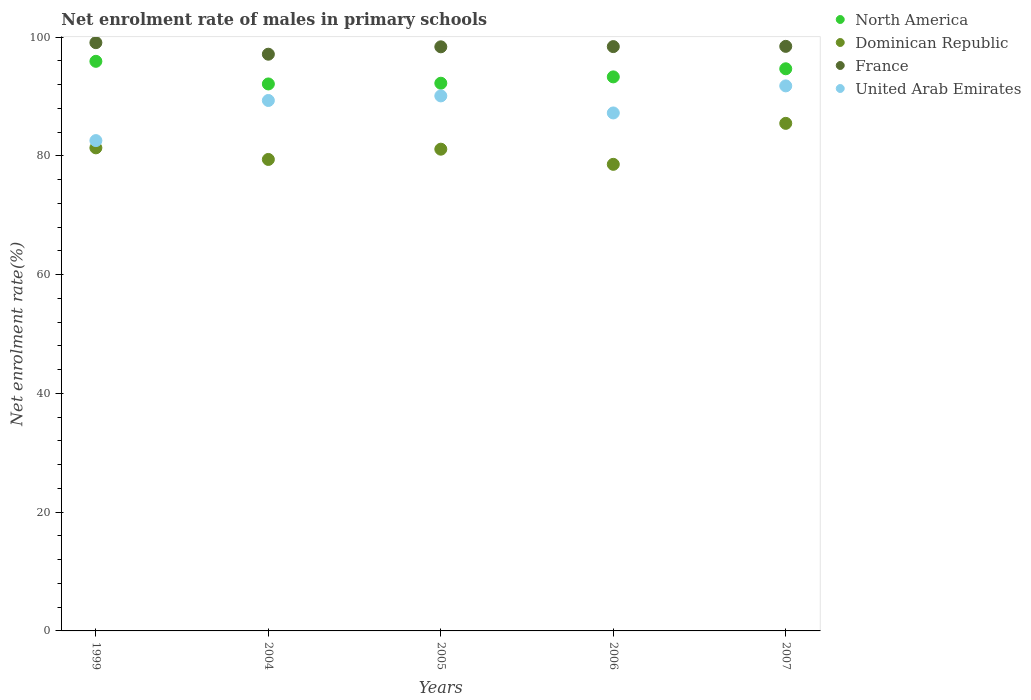How many different coloured dotlines are there?
Your answer should be compact. 4. Is the number of dotlines equal to the number of legend labels?
Offer a very short reply. Yes. What is the net enrolment rate of males in primary schools in United Arab Emirates in 2006?
Your answer should be compact. 87.25. Across all years, what is the maximum net enrolment rate of males in primary schools in United Arab Emirates?
Provide a succinct answer. 91.8. Across all years, what is the minimum net enrolment rate of males in primary schools in Dominican Republic?
Offer a terse response. 78.59. In which year was the net enrolment rate of males in primary schools in France maximum?
Offer a very short reply. 1999. What is the total net enrolment rate of males in primary schools in Dominican Republic in the graph?
Your response must be concise. 406.01. What is the difference between the net enrolment rate of males in primary schools in France in 2004 and that in 2007?
Offer a very short reply. -1.32. What is the difference between the net enrolment rate of males in primary schools in France in 2006 and the net enrolment rate of males in primary schools in United Arab Emirates in 2007?
Keep it short and to the point. 6.62. What is the average net enrolment rate of males in primary schools in United Arab Emirates per year?
Your response must be concise. 88.22. In the year 1999, what is the difference between the net enrolment rate of males in primary schools in France and net enrolment rate of males in primary schools in Dominican Republic?
Provide a short and direct response. 17.72. In how many years, is the net enrolment rate of males in primary schools in North America greater than 84 %?
Your answer should be very brief. 5. What is the ratio of the net enrolment rate of males in primary schools in United Arab Emirates in 1999 to that in 2006?
Offer a very short reply. 0.95. What is the difference between the highest and the second highest net enrolment rate of males in primary schools in United Arab Emirates?
Your answer should be very brief. 1.69. What is the difference between the highest and the lowest net enrolment rate of males in primary schools in Dominican Republic?
Keep it short and to the point. 6.9. Is it the case that in every year, the sum of the net enrolment rate of males in primary schools in North America and net enrolment rate of males in primary schools in France  is greater than the sum of net enrolment rate of males in primary schools in Dominican Republic and net enrolment rate of males in primary schools in United Arab Emirates?
Keep it short and to the point. Yes. Does the net enrolment rate of males in primary schools in Dominican Republic monotonically increase over the years?
Give a very brief answer. No. Is the net enrolment rate of males in primary schools in United Arab Emirates strictly greater than the net enrolment rate of males in primary schools in North America over the years?
Your answer should be very brief. No. How many dotlines are there?
Your answer should be very brief. 4. Does the graph contain any zero values?
Your answer should be compact. No. How are the legend labels stacked?
Make the answer very short. Vertical. What is the title of the graph?
Keep it short and to the point. Net enrolment rate of males in primary schools. Does "Central African Republic" appear as one of the legend labels in the graph?
Offer a very short reply. No. What is the label or title of the X-axis?
Provide a succinct answer. Years. What is the label or title of the Y-axis?
Ensure brevity in your answer.  Net enrolment rate(%). What is the Net enrolment rate(%) in North America in 1999?
Offer a very short reply. 95.94. What is the Net enrolment rate(%) of Dominican Republic in 1999?
Keep it short and to the point. 81.37. What is the Net enrolment rate(%) in France in 1999?
Your answer should be compact. 99.09. What is the Net enrolment rate(%) of United Arab Emirates in 1999?
Give a very brief answer. 82.59. What is the Net enrolment rate(%) in North America in 2004?
Give a very brief answer. 92.13. What is the Net enrolment rate(%) of Dominican Republic in 2004?
Give a very brief answer. 79.41. What is the Net enrolment rate(%) of France in 2004?
Your answer should be very brief. 97.14. What is the Net enrolment rate(%) of United Arab Emirates in 2004?
Your answer should be compact. 89.35. What is the Net enrolment rate(%) of North America in 2005?
Provide a succinct answer. 92.25. What is the Net enrolment rate(%) in Dominican Republic in 2005?
Provide a short and direct response. 81.14. What is the Net enrolment rate(%) of France in 2005?
Your answer should be very brief. 98.39. What is the Net enrolment rate(%) in United Arab Emirates in 2005?
Keep it short and to the point. 90.12. What is the Net enrolment rate(%) in North America in 2006?
Provide a succinct answer. 93.32. What is the Net enrolment rate(%) of Dominican Republic in 2006?
Make the answer very short. 78.59. What is the Net enrolment rate(%) in France in 2006?
Your response must be concise. 98.42. What is the Net enrolment rate(%) of United Arab Emirates in 2006?
Your answer should be compact. 87.25. What is the Net enrolment rate(%) of North America in 2007?
Your answer should be compact. 94.69. What is the Net enrolment rate(%) of Dominican Republic in 2007?
Offer a very short reply. 85.49. What is the Net enrolment rate(%) of France in 2007?
Provide a short and direct response. 98.46. What is the Net enrolment rate(%) in United Arab Emirates in 2007?
Give a very brief answer. 91.8. Across all years, what is the maximum Net enrolment rate(%) in North America?
Ensure brevity in your answer.  95.94. Across all years, what is the maximum Net enrolment rate(%) of Dominican Republic?
Offer a terse response. 85.49. Across all years, what is the maximum Net enrolment rate(%) of France?
Ensure brevity in your answer.  99.09. Across all years, what is the maximum Net enrolment rate(%) in United Arab Emirates?
Ensure brevity in your answer.  91.8. Across all years, what is the minimum Net enrolment rate(%) of North America?
Provide a succinct answer. 92.13. Across all years, what is the minimum Net enrolment rate(%) in Dominican Republic?
Your response must be concise. 78.59. Across all years, what is the minimum Net enrolment rate(%) of France?
Offer a terse response. 97.14. Across all years, what is the minimum Net enrolment rate(%) in United Arab Emirates?
Ensure brevity in your answer.  82.59. What is the total Net enrolment rate(%) in North America in the graph?
Make the answer very short. 468.33. What is the total Net enrolment rate(%) of Dominican Republic in the graph?
Give a very brief answer. 406.01. What is the total Net enrolment rate(%) in France in the graph?
Provide a short and direct response. 491.49. What is the total Net enrolment rate(%) in United Arab Emirates in the graph?
Keep it short and to the point. 441.1. What is the difference between the Net enrolment rate(%) in North America in 1999 and that in 2004?
Ensure brevity in your answer.  3.81. What is the difference between the Net enrolment rate(%) of Dominican Republic in 1999 and that in 2004?
Offer a terse response. 1.95. What is the difference between the Net enrolment rate(%) in France in 1999 and that in 2004?
Your answer should be compact. 1.95. What is the difference between the Net enrolment rate(%) of United Arab Emirates in 1999 and that in 2004?
Give a very brief answer. -6.76. What is the difference between the Net enrolment rate(%) in North America in 1999 and that in 2005?
Provide a short and direct response. 3.69. What is the difference between the Net enrolment rate(%) of Dominican Republic in 1999 and that in 2005?
Offer a very short reply. 0.23. What is the difference between the Net enrolment rate(%) of United Arab Emirates in 1999 and that in 2005?
Give a very brief answer. -7.53. What is the difference between the Net enrolment rate(%) in North America in 1999 and that in 2006?
Give a very brief answer. 2.62. What is the difference between the Net enrolment rate(%) in Dominican Republic in 1999 and that in 2006?
Your answer should be compact. 2.78. What is the difference between the Net enrolment rate(%) of France in 1999 and that in 2006?
Your answer should be compact. 0.66. What is the difference between the Net enrolment rate(%) of United Arab Emirates in 1999 and that in 2006?
Make the answer very short. -4.66. What is the difference between the Net enrolment rate(%) in North America in 1999 and that in 2007?
Give a very brief answer. 1.26. What is the difference between the Net enrolment rate(%) in Dominican Republic in 1999 and that in 2007?
Your answer should be compact. -4.13. What is the difference between the Net enrolment rate(%) of France in 1999 and that in 2007?
Your answer should be compact. 0.62. What is the difference between the Net enrolment rate(%) of United Arab Emirates in 1999 and that in 2007?
Give a very brief answer. -9.22. What is the difference between the Net enrolment rate(%) in North America in 2004 and that in 2005?
Your answer should be compact. -0.12. What is the difference between the Net enrolment rate(%) in Dominican Republic in 2004 and that in 2005?
Make the answer very short. -1.73. What is the difference between the Net enrolment rate(%) of France in 2004 and that in 2005?
Provide a succinct answer. -1.25. What is the difference between the Net enrolment rate(%) of United Arab Emirates in 2004 and that in 2005?
Your answer should be very brief. -0.77. What is the difference between the Net enrolment rate(%) of North America in 2004 and that in 2006?
Provide a short and direct response. -1.19. What is the difference between the Net enrolment rate(%) in Dominican Republic in 2004 and that in 2006?
Give a very brief answer. 0.83. What is the difference between the Net enrolment rate(%) in France in 2004 and that in 2006?
Offer a terse response. -1.28. What is the difference between the Net enrolment rate(%) of United Arab Emirates in 2004 and that in 2006?
Provide a short and direct response. 2.1. What is the difference between the Net enrolment rate(%) in North America in 2004 and that in 2007?
Your response must be concise. -2.55. What is the difference between the Net enrolment rate(%) of Dominican Republic in 2004 and that in 2007?
Provide a short and direct response. -6.08. What is the difference between the Net enrolment rate(%) of France in 2004 and that in 2007?
Ensure brevity in your answer.  -1.32. What is the difference between the Net enrolment rate(%) in United Arab Emirates in 2004 and that in 2007?
Give a very brief answer. -2.46. What is the difference between the Net enrolment rate(%) of North America in 2005 and that in 2006?
Your response must be concise. -1.07. What is the difference between the Net enrolment rate(%) in Dominican Republic in 2005 and that in 2006?
Keep it short and to the point. 2.55. What is the difference between the Net enrolment rate(%) in France in 2005 and that in 2006?
Offer a terse response. -0.04. What is the difference between the Net enrolment rate(%) in United Arab Emirates in 2005 and that in 2006?
Your response must be concise. 2.87. What is the difference between the Net enrolment rate(%) in North America in 2005 and that in 2007?
Offer a very short reply. -2.43. What is the difference between the Net enrolment rate(%) of Dominican Republic in 2005 and that in 2007?
Provide a succinct answer. -4.35. What is the difference between the Net enrolment rate(%) of France in 2005 and that in 2007?
Provide a succinct answer. -0.08. What is the difference between the Net enrolment rate(%) of United Arab Emirates in 2005 and that in 2007?
Your answer should be very brief. -1.69. What is the difference between the Net enrolment rate(%) in North America in 2006 and that in 2007?
Provide a succinct answer. -1.37. What is the difference between the Net enrolment rate(%) of Dominican Republic in 2006 and that in 2007?
Offer a terse response. -6.9. What is the difference between the Net enrolment rate(%) in France in 2006 and that in 2007?
Your answer should be compact. -0.04. What is the difference between the Net enrolment rate(%) in United Arab Emirates in 2006 and that in 2007?
Offer a terse response. -4.56. What is the difference between the Net enrolment rate(%) of North America in 1999 and the Net enrolment rate(%) of Dominican Republic in 2004?
Your response must be concise. 16.53. What is the difference between the Net enrolment rate(%) in North America in 1999 and the Net enrolment rate(%) in France in 2004?
Your answer should be very brief. -1.2. What is the difference between the Net enrolment rate(%) in North America in 1999 and the Net enrolment rate(%) in United Arab Emirates in 2004?
Ensure brevity in your answer.  6.6. What is the difference between the Net enrolment rate(%) in Dominican Republic in 1999 and the Net enrolment rate(%) in France in 2004?
Provide a succinct answer. -15.77. What is the difference between the Net enrolment rate(%) in Dominican Republic in 1999 and the Net enrolment rate(%) in United Arab Emirates in 2004?
Your answer should be very brief. -7.98. What is the difference between the Net enrolment rate(%) of France in 1999 and the Net enrolment rate(%) of United Arab Emirates in 2004?
Provide a short and direct response. 9.74. What is the difference between the Net enrolment rate(%) of North America in 1999 and the Net enrolment rate(%) of Dominican Republic in 2005?
Make the answer very short. 14.8. What is the difference between the Net enrolment rate(%) in North America in 1999 and the Net enrolment rate(%) in France in 2005?
Offer a terse response. -2.44. What is the difference between the Net enrolment rate(%) of North America in 1999 and the Net enrolment rate(%) of United Arab Emirates in 2005?
Provide a short and direct response. 5.82. What is the difference between the Net enrolment rate(%) of Dominican Republic in 1999 and the Net enrolment rate(%) of France in 2005?
Offer a very short reply. -17.02. What is the difference between the Net enrolment rate(%) in Dominican Republic in 1999 and the Net enrolment rate(%) in United Arab Emirates in 2005?
Make the answer very short. -8.75. What is the difference between the Net enrolment rate(%) in France in 1999 and the Net enrolment rate(%) in United Arab Emirates in 2005?
Your response must be concise. 8.97. What is the difference between the Net enrolment rate(%) of North America in 1999 and the Net enrolment rate(%) of Dominican Republic in 2006?
Your answer should be compact. 17.35. What is the difference between the Net enrolment rate(%) of North America in 1999 and the Net enrolment rate(%) of France in 2006?
Give a very brief answer. -2.48. What is the difference between the Net enrolment rate(%) in North America in 1999 and the Net enrolment rate(%) in United Arab Emirates in 2006?
Offer a very short reply. 8.7. What is the difference between the Net enrolment rate(%) of Dominican Republic in 1999 and the Net enrolment rate(%) of France in 2006?
Provide a short and direct response. -17.05. What is the difference between the Net enrolment rate(%) of Dominican Republic in 1999 and the Net enrolment rate(%) of United Arab Emirates in 2006?
Your answer should be very brief. -5.88. What is the difference between the Net enrolment rate(%) of France in 1999 and the Net enrolment rate(%) of United Arab Emirates in 2006?
Offer a terse response. 11.84. What is the difference between the Net enrolment rate(%) in North America in 1999 and the Net enrolment rate(%) in Dominican Republic in 2007?
Keep it short and to the point. 10.45. What is the difference between the Net enrolment rate(%) in North America in 1999 and the Net enrolment rate(%) in France in 2007?
Make the answer very short. -2.52. What is the difference between the Net enrolment rate(%) of North America in 1999 and the Net enrolment rate(%) of United Arab Emirates in 2007?
Offer a terse response. 4.14. What is the difference between the Net enrolment rate(%) of Dominican Republic in 1999 and the Net enrolment rate(%) of France in 2007?
Offer a very short reply. -17.09. What is the difference between the Net enrolment rate(%) of Dominican Republic in 1999 and the Net enrolment rate(%) of United Arab Emirates in 2007?
Give a very brief answer. -10.44. What is the difference between the Net enrolment rate(%) of France in 1999 and the Net enrolment rate(%) of United Arab Emirates in 2007?
Keep it short and to the point. 7.28. What is the difference between the Net enrolment rate(%) of North America in 2004 and the Net enrolment rate(%) of Dominican Republic in 2005?
Ensure brevity in your answer.  10.99. What is the difference between the Net enrolment rate(%) of North America in 2004 and the Net enrolment rate(%) of France in 2005?
Provide a succinct answer. -6.25. What is the difference between the Net enrolment rate(%) of North America in 2004 and the Net enrolment rate(%) of United Arab Emirates in 2005?
Your answer should be compact. 2.01. What is the difference between the Net enrolment rate(%) of Dominican Republic in 2004 and the Net enrolment rate(%) of France in 2005?
Your response must be concise. -18.97. What is the difference between the Net enrolment rate(%) of Dominican Republic in 2004 and the Net enrolment rate(%) of United Arab Emirates in 2005?
Offer a very short reply. -10.7. What is the difference between the Net enrolment rate(%) in France in 2004 and the Net enrolment rate(%) in United Arab Emirates in 2005?
Offer a very short reply. 7.02. What is the difference between the Net enrolment rate(%) in North America in 2004 and the Net enrolment rate(%) in Dominican Republic in 2006?
Give a very brief answer. 13.54. What is the difference between the Net enrolment rate(%) in North America in 2004 and the Net enrolment rate(%) in France in 2006?
Your response must be concise. -6.29. What is the difference between the Net enrolment rate(%) of North America in 2004 and the Net enrolment rate(%) of United Arab Emirates in 2006?
Provide a succinct answer. 4.89. What is the difference between the Net enrolment rate(%) of Dominican Republic in 2004 and the Net enrolment rate(%) of France in 2006?
Ensure brevity in your answer.  -19.01. What is the difference between the Net enrolment rate(%) in Dominican Republic in 2004 and the Net enrolment rate(%) in United Arab Emirates in 2006?
Your answer should be compact. -7.83. What is the difference between the Net enrolment rate(%) in France in 2004 and the Net enrolment rate(%) in United Arab Emirates in 2006?
Give a very brief answer. 9.89. What is the difference between the Net enrolment rate(%) of North America in 2004 and the Net enrolment rate(%) of Dominican Republic in 2007?
Offer a very short reply. 6.64. What is the difference between the Net enrolment rate(%) in North America in 2004 and the Net enrolment rate(%) in France in 2007?
Give a very brief answer. -6.33. What is the difference between the Net enrolment rate(%) of North America in 2004 and the Net enrolment rate(%) of United Arab Emirates in 2007?
Make the answer very short. 0.33. What is the difference between the Net enrolment rate(%) of Dominican Republic in 2004 and the Net enrolment rate(%) of France in 2007?
Offer a terse response. -19.05. What is the difference between the Net enrolment rate(%) in Dominican Republic in 2004 and the Net enrolment rate(%) in United Arab Emirates in 2007?
Provide a succinct answer. -12.39. What is the difference between the Net enrolment rate(%) of France in 2004 and the Net enrolment rate(%) of United Arab Emirates in 2007?
Give a very brief answer. 5.34. What is the difference between the Net enrolment rate(%) in North America in 2005 and the Net enrolment rate(%) in Dominican Republic in 2006?
Offer a very short reply. 13.66. What is the difference between the Net enrolment rate(%) of North America in 2005 and the Net enrolment rate(%) of France in 2006?
Provide a succinct answer. -6.17. What is the difference between the Net enrolment rate(%) in North America in 2005 and the Net enrolment rate(%) in United Arab Emirates in 2006?
Give a very brief answer. 5.01. What is the difference between the Net enrolment rate(%) in Dominican Republic in 2005 and the Net enrolment rate(%) in France in 2006?
Your response must be concise. -17.28. What is the difference between the Net enrolment rate(%) of Dominican Republic in 2005 and the Net enrolment rate(%) of United Arab Emirates in 2006?
Keep it short and to the point. -6.1. What is the difference between the Net enrolment rate(%) of France in 2005 and the Net enrolment rate(%) of United Arab Emirates in 2006?
Your answer should be very brief. 11.14. What is the difference between the Net enrolment rate(%) of North America in 2005 and the Net enrolment rate(%) of Dominican Republic in 2007?
Your answer should be compact. 6.76. What is the difference between the Net enrolment rate(%) of North America in 2005 and the Net enrolment rate(%) of France in 2007?
Keep it short and to the point. -6.21. What is the difference between the Net enrolment rate(%) in North America in 2005 and the Net enrolment rate(%) in United Arab Emirates in 2007?
Keep it short and to the point. 0.45. What is the difference between the Net enrolment rate(%) of Dominican Republic in 2005 and the Net enrolment rate(%) of France in 2007?
Give a very brief answer. -17.32. What is the difference between the Net enrolment rate(%) in Dominican Republic in 2005 and the Net enrolment rate(%) in United Arab Emirates in 2007?
Your answer should be very brief. -10.66. What is the difference between the Net enrolment rate(%) in France in 2005 and the Net enrolment rate(%) in United Arab Emirates in 2007?
Make the answer very short. 6.58. What is the difference between the Net enrolment rate(%) in North America in 2006 and the Net enrolment rate(%) in Dominican Republic in 2007?
Ensure brevity in your answer.  7.83. What is the difference between the Net enrolment rate(%) of North America in 2006 and the Net enrolment rate(%) of France in 2007?
Offer a terse response. -5.14. What is the difference between the Net enrolment rate(%) in North America in 2006 and the Net enrolment rate(%) in United Arab Emirates in 2007?
Your answer should be compact. 1.52. What is the difference between the Net enrolment rate(%) in Dominican Republic in 2006 and the Net enrolment rate(%) in France in 2007?
Your answer should be very brief. -19.87. What is the difference between the Net enrolment rate(%) of Dominican Republic in 2006 and the Net enrolment rate(%) of United Arab Emirates in 2007?
Offer a terse response. -13.21. What is the difference between the Net enrolment rate(%) in France in 2006 and the Net enrolment rate(%) in United Arab Emirates in 2007?
Provide a succinct answer. 6.62. What is the average Net enrolment rate(%) of North America per year?
Your answer should be very brief. 93.67. What is the average Net enrolment rate(%) in Dominican Republic per year?
Your answer should be very brief. 81.2. What is the average Net enrolment rate(%) of France per year?
Make the answer very short. 98.3. What is the average Net enrolment rate(%) of United Arab Emirates per year?
Provide a succinct answer. 88.22. In the year 1999, what is the difference between the Net enrolment rate(%) of North America and Net enrolment rate(%) of Dominican Republic?
Provide a short and direct response. 14.57. In the year 1999, what is the difference between the Net enrolment rate(%) of North America and Net enrolment rate(%) of France?
Provide a succinct answer. -3.14. In the year 1999, what is the difference between the Net enrolment rate(%) of North America and Net enrolment rate(%) of United Arab Emirates?
Keep it short and to the point. 13.35. In the year 1999, what is the difference between the Net enrolment rate(%) in Dominican Republic and Net enrolment rate(%) in France?
Provide a short and direct response. -17.72. In the year 1999, what is the difference between the Net enrolment rate(%) in Dominican Republic and Net enrolment rate(%) in United Arab Emirates?
Offer a very short reply. -1.22. In the year 1999, what is the difference between the Net enrolment rate(%) in France and Net enrolment rate(%) in United Arab Emirates?
Offer a terse response. 16.5. In the year 2004, what is the difference between the Net enrolment rate(%) of North America and Net enrolment rate(%) of Dominican Republic?
Provide a short and direct response. 12.72. In the year 2004, what is the difference between the Net enrolment rate(%) of North America and Net enrolment rate(%) of France?
Your answer should be very brief. -5.01. In the year 2004, what is the difference between the Net enrolment rate(%) in North America and Net enrolment rate(%) in United Arab Emirates?
Give a very brief answer. 2.79. In the year 2004, what is the difference between the Net enrolment rate(%) of Dominican Republic and Net enrolment rate(%) of France?
Make the answer very short. -17.72. In the year 2004, what is the difference between the Net enrolment rate(%) in Dominican Republic and Net enrolment rate(%) in United Arab Emirates?
Your response must be concise. -9.93. In the year 2004, what is the difference between the Net enrolment rate(%) in France and Net enrolment rate(%) in United Arab Emirates?
Your response must be concise. 7.79. In the year 2005, what is the difference between the Net enrolment rate(%) in North America and Net enrolment rate(%) in Dominican Republic?
Your response must be concise. 11.11. In the year 2005, what is the difference between the Net enrolment rate(%) of North America and Net enrolment rate(%) of France?
Provide a succinct answer. -6.13. In the year 2005, what is the difference between the Net enrolment rate(%) of North America and Net enrolment rate(%) of United Arab Emirates?
Your answer should be very brief. 2.14. In the year 2005, what is the difference between the Net enrolment rate(%) in Dominican Republic and Net enrolment rate(%) in France?
Provide a succinct answer. -17.24. In the year 2005, what is the difference between the Net enrolment rate(%) of Dominican Republic and Net enrolment rate(%) of United Arab Emirates?
Offer a very short reply. -8.97. In the year 2005, what is the difference between the Net enrolment rate(%) in France and Net enrolment rate(%) in United Arab Emirates?
Your response must be concise. 8.27. In the year 2006, what is the difference between the Net enrolment rate(%) of North America and Net enrolment rate(%) of Dominican Republic?
Keep it short and to the point. 14.73. In the year 2006, what is the difference between the Net enrolment rate(%) in North America and Net enrolment rate(%) in France?
Ensure brevity in your answer.  -5.1. In the year 2006, what is the difference between the Net enrolment rate(%) in North America and Net enrolment rate(%) in United Arab Emirates?
Ensure brevity in your answer.  6.07. In the year 2006, what is the difference between the Net enrolment rate(%) in Dominican Republic and Net enrolment rate(%) in France?
Provide a short and direct response. -19.83. In the year 2006, what is the difference between the Net enrolment rate(%) in Dominican Republic and Net enrolment rate(%) in United Arab Emirates?
Offer a very short reply. -8.66. In the year 2006, what is the difference between the Net enrolment rate(%) in France and Net enrolment rate(%) in United Arab Emirates?
Keep it short and to the point. 11.18. In the year 2007, what is the difference between the Net enrolment rate(%) of North America and Net enrolment rate(%) of Dominican Republic?
Your answer should be very brief. 9.19. In the year 2007, what is the difference between the Net enrolment rate(%) in North America and Net enrolment rate(%) in France?
Ensure brevity in your answer.  -3.78. In the year 2007, what is the difference between the Net enrolment rate(%) of North America and Net enrolment rate(%) of United Arab Emirates?
Provide a succinct answer. 2.88. In the year 2007, what is the difference between the Net enrolment rate(%) in Dominican Republic and Net enrolment rate(%) in France?
Offer a terse response. -12.97. In the year 2007, what is the difference between the Net enrolment rate(%) of Dominican Republic and Net enrolment rate(%) of United Arab Emirates?
Provide a succinct answer. -6.31. In the year 2007, what is the difference between the Net enrolment rate(%) of France and Net enrolment rate(%) of United Arab Emirates?
Provide a succinct answer. 6.66. What is the ratio of the Net enrolment rate(%) in North America in 1999 to that in 2004?
Offer a very short reply. 1.04. What is the ratio of the Net enrolment rate(%) in Dominican Republic in 1999 to that in 2004?
Give a very brief answer. 1.02. What is the ratio of the Net enrolment rate(%) of United Arab Emirates in 1999 to that in 2004?
Your answer should be compact. 0.92. What is the ratio of the Net enrolment rate(%) in North America in 1999 to that in 2005?
Provide a short and direct response. 1.04. What is the ratio of the Net enrolment rate(%) in Dominican Republic in 1999 to that in 2005?
Your response must be concise. 1. What is the ratio of the Net enrolment rate(%) of France in 1999 to that in 2005?
Your answer should be compact. 1.01. What is the ratio of the Net enrolment rate(%) of United Arab Emirates in 1999 to that in 2005?
Your response must be concise. 0.92. What is the ratio of the Net enrolment rate(%) in North America in 1999 to that in 2006?
Your answer should be very brief. 1.03. What is the ratio of the Net enrolment rate(%) of Dominican Republic in 1999 to that in 2006?
Your answer should be very brief. 1.04. What is the ratio of the Net enrolment rate(%) in France in 1999 to that in 2006?
Keep it short and to the point. 1.01. What is the ratio of the Net enrolment rate(%) in United Arab Emirates in 1999 to that in 2006?
Your response must be concise. 0.95. What is the ratio of the Net enrolment rate(%) in North America in 1999 to that in 2007?
Keep it short and to the point. 1.01. What is the ratio of the Net enrolment rate(%) of Dominican Republic in 1999 to that in 2007?
Your answer should be compact. 0.95. What is the ratio of the Net enrolment rate(%) of United Arab Emirates in 1999 to that in 2007?
Your answer should be compact. 0.9. What is the ratio of the Net enrolment rate(%) in North America in 2004 to that in 2005?
Your response must be concise. 1. What is the ratio of the Net enrolment rate(%) of Dominican Republic in 2004 to that in 2005?
Give a very brief answer. 0.98. What is the ratio of the Net enrolment rate(%) of France in 2004 to that in 2005?
Provide a short and direct response. 0.99. What is the ratio of the Net enrolment rate(%) in United Arab Emirates in 2004 to that in 2005?
Keep it short and to the point. 0.99. What is the ratio of the Net enrolment rate(%) of North America in 2004 to that in 2006?
Your response must be concise. 0.99. What is the ratio of the Net enrolment rate(%) of Dominican Republic in 2004 to that in 2006?
Offer a very short reply. 1.01. What is the ratio of the Net enrolment rate(%) in France in 2004 to that in 2006?
Ensure brevity in your answer.  0.99. What is the ratio of the Net enrolment rate(%) of United Arab Emirates in 2004 to that in 2006?
Give a very brief answer. 1.02. What is the ratio of the Net enrolment rate(%) in North America in 2004 to that in 2007?
Offer a terse response. 0.97. What is the ratio of the Net enrolment rate(%) of Dominican Republic in 2004 to that in 2007?
Offer a very short reply. 0.93. What is the ratio of the Net enrolment rate(%) of France in 2004 to that in 2007?
Ensure brevity in your answer.  0.99. What is the ratio of the Net enrolment rate(%) of United Arab Emirates in 2004 to that in 2007?
Provide a short and direct response. 0.97. What is the ratio of the Net enrolment rate(%) in Dominican Republic in 2005 to that in 2006?
Your response must be concise. 1.03. What is the ratio of the Net enrolment rate(%) in France in 2005 to that in 2006?
Give a very brief answer. 1. What is the ratio of the Net enrolment rate(%) of United Arab Emirates in 2005 to that in 2006?
Keep it short and to the point. 1.03. What is the ratio of the Net enrolment rate(%) of North America in 2005 to that in 2007?
Your answer should be compact. 0.97. What is the ratio of the Net enrolment rate(%) in Dominican Republic in 2005 to that in 2007?
Provide a short and direct response. 0.95. What is the ratio of the Net enrolment rate(%) of France in 2005 to that in 2007?
Make the answer very short. 1. What is the ratio of the Net enrolment rate(%) in United Arab Emirates in 2005 to that in 2007?
Give a very brief answer. 0.98. What is the ratio of the Net enrolment rate(%) in North America in 2006 to that in 2007?
Your answer should be compact. 0.99. What is the ratio of the Net enrolment rate(%) in Dominican Republic in 2006 to that in 2007?
Ensure brevity in your answer.  0.92. What is the ratio of the Net enrolment rate(%) of France in 2006 to that in 2007?
Offer a terse response. 1. What is the ratio of the Net enrolment rate(%) of United Arab Emirates in 2006 to that in 2007?
Give a very brief answer. 0.95. What is the difference between the highest and the second highest Net enrolment rate(%) of North America?
Ensure brevity in your answer.  1.26. What is the difference between the highest and the second highest Net enrolment rate(%) of Dominican Republic?
Give a very brief answer. 4.13. What is the difference between the highest and the second highest Net enrolment rate(%) of France?
Offer a terse response. 0.62. What is the difference between the highest and the second highest Net enrolment rate(%) of United Arab Emirates?
Your answer should be very brief. 1.69. What is the difference between the highest and the lowest Net enrolment rate(%) of North America?
Make the answer very short. 3.81. What is the difference between the highest and the lowest Net enrolment rate(%) of Dominican Republic?
Your answer should be compact. 6.9. What is the difference between the highest and the lowest Net enrolment rate(%) of France?
Make the answer very short. 1.95. What is the difference between the highest and the lowest Net enrolment rate(%) of United Arab Emirates?
Your answer should be very brief. 9.22. 